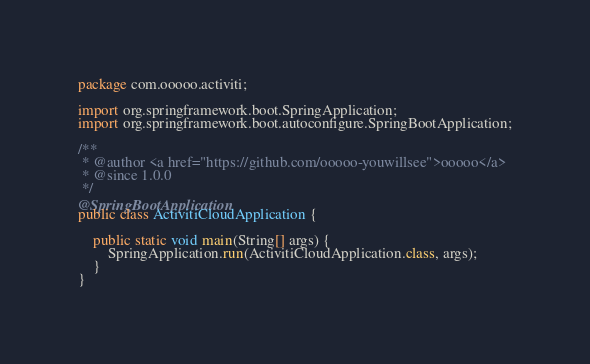Convert code to text. <code><loc_0><loc_0><loc_500><loc_500><_Java_>package com.ooooo.activiti;

import org.springframework.boot.SpringApplication;
import org.springframework.boot.autoconfigure.SpringBootApplication;

/**
 * @author <a href="https://github.com/ooooo-youwillsee">ooooo</a>
 * @since 1.0.0
 */
@SpringBootApplication
public class ActivitiCloudApplication {
	
	public static void main(String[] args) {
		SpringApplication.run(ActivitiCloudApplication.class, args);
	}
}
</code> 